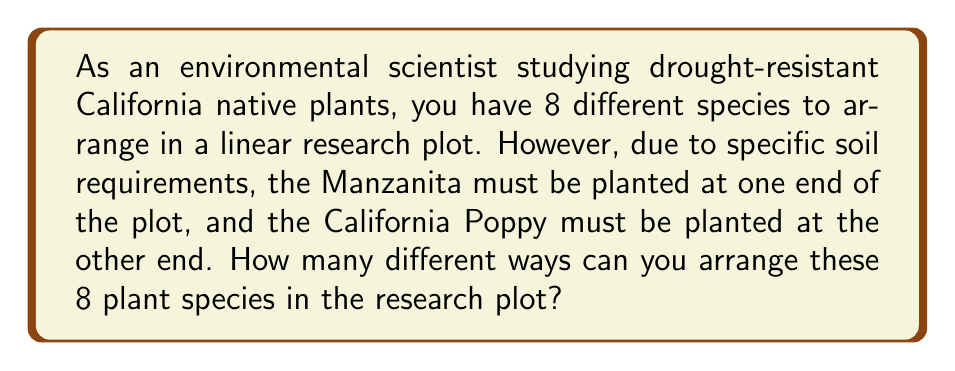Help me with this question. Let's approach this step-by-step:

1) We have 8 total plant species, but two of them (Manzanita and California Poppy) have fixed positions at the ends of the plot.

2) This means we only need to arrange the remaining 6 species in the middle 6 positions.

3) This is a straightforward permutation problem. We are arranging 6 distinct objects (plant species) in 6 positions.

4) The number of permutations of n distinct objects is given by the formula:

   $$P(n) = n!$$

5) In this case, n = 6, so we calculate:

   $$P(6) = 6!$$

6) Let's expand this:

   $$6! = 6 \times 5 \times 4 \times 3 \times 2 \times 1 = 720$$

Therefore, there are 720 different ways to arrange these 8 plant species in the research plot, given the constraints on the Manzanita and California Poppy.
Answer: 720 